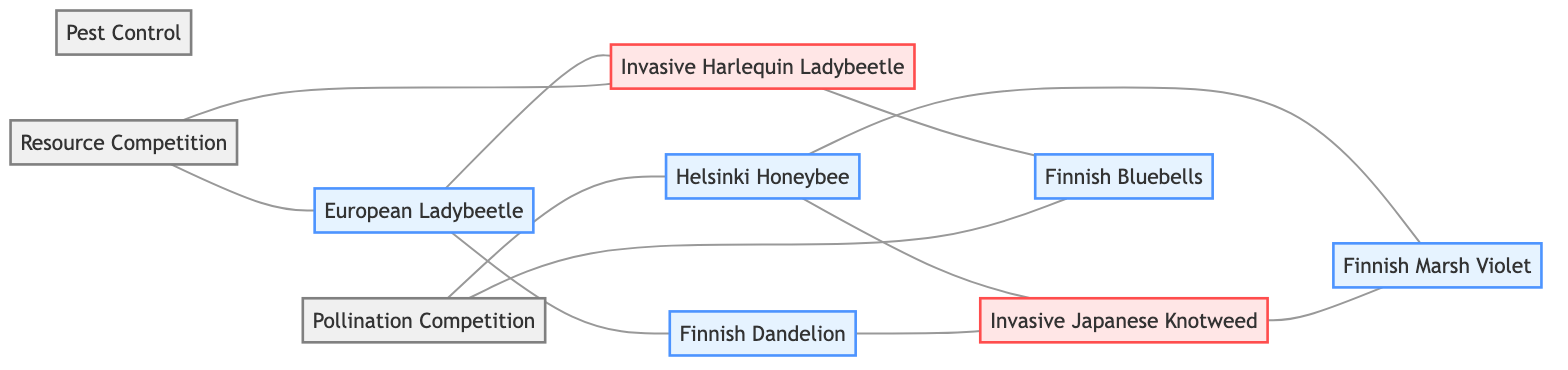What species does the Helsinki Honeybee pollinate? The diagram shows an edge connecting the Helsinki Honeybee to two nodes: Finnish Marsh Violet and Invasive Japanese Knotweed. Hence, both species are pollinated by the Helsinki Honeybee.
Answer: Finnish Marsh Violet, Invasive Japanese Knotweed How many native species are in the diagram? The nodes labeled as native species include: Helsinki Honeybee, Finnish Marsh Violet, European Ladybeetle, Finnish Bluebells, and Finnish Dandelion, totaling five native species.
Answer: 5 Which invasive species negatively impacts Finnish Bluebells? The diagram shows an edge from the Invasive Harlequin Ladybeetle to Finnish Bluebells labeled as negatively impacts, indicating that this invasive species is the one that negatively impacts Finnish Bluebells.
Answer: Invasive Harlequin Ladybeetle What is the relationship between the European Ladybeetle and the Invasive Harlequin Ladybeetle? The diagram shows that the European Ladybeetle competes with the Invasive Harlequin Ladybeetle, as indicated by the connecting edge labeled competes with.
Answer: competes with Which native species is affected by Pollination Competition? The edges drawn from Pollination Competition lead to the Helsinki Honeybee and Finnish Bluebells, indicating that both are affected by Pollination Competition.
Answer: Helsinki Honeybee, Finnish Bluebells How many edges are connected to the Invasive Japanese Knotweed? There are three edges connected to Invasive Japanese Knotweed: one with Helsinki Honeybee (pollinates), one with Finnish Marsh Violet (competes with), and one with Finnish Dandelion (competes with), leading to a total of three edges.
Answer: 3 What type of interaction affects the European Ladybeetle? The diagram shows that Resource Competition affects the European Ladybeetle, evidenced by the edge connecting the two labeled affects.
Answer: Resource Competition Which species competes with Finnish Dandelion? The diagram connects Finnish Dandelion to the Invasive Japanese Knotweed with an edge labeled competes with, indicating that Invasive Japanese Knotweed competes with Finnish Dandelion.
Answer: Invasive Japanese Knotweed 